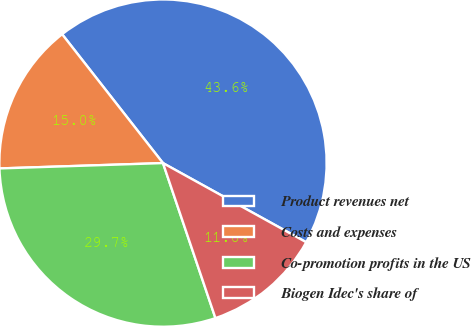Convert chart to OTSL. <chart><loc_0><loc_0><loc_500><loc_500><pie_chart><fcel>Product revenues net<fcel>Costs and expenses<fcel>Co-promotion profits in the US<fcel>Biogen Idec's share of<nl><fcel>43.6%<fcel>14.95%<fcel>29.67%<fcel>11.77%<nl></chart> 